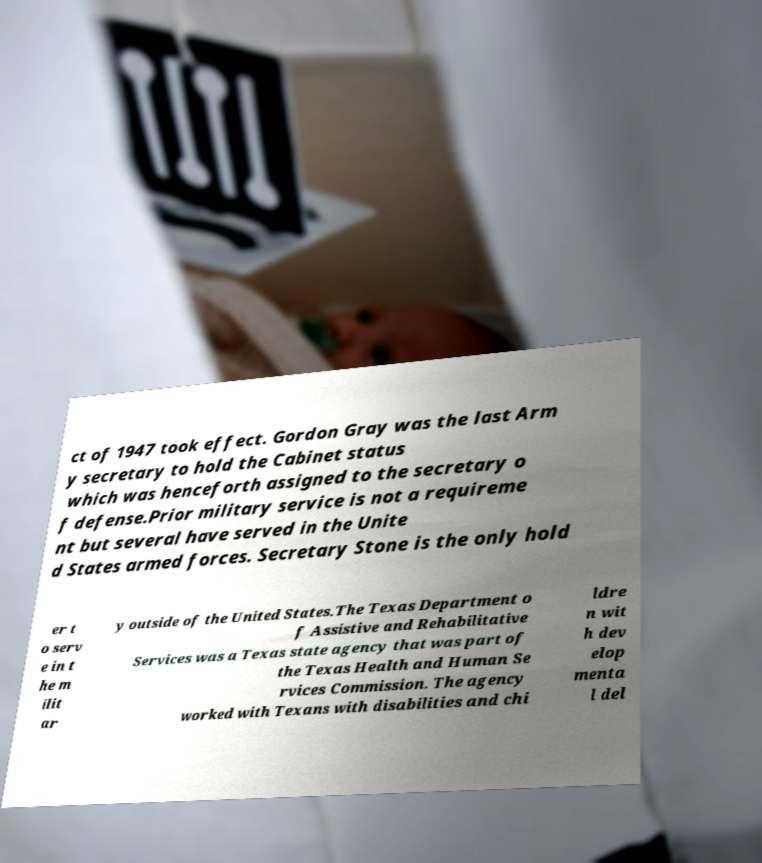I need the written content from this picture converted into text. Can you do that? ct of 1947 took effect. Gordon Gray was the last Arm y secretary to hold the Cabinet status which was henceforth assigned to the secretary o f defense.Prior military service is not a requireme nt but several have served in the Unite d States armed forces. Secretary Stone is the only hold er t o serv e in t he m ilit ar y outside of the United States.The Texas Department o f Assistive and Rehabilitative Services was a Texas state agency that was part of the Texas Health and Human Se rvices Commission. The agency worked with Texans with disabilities and chi ldre n wit h dev elop menta l del 